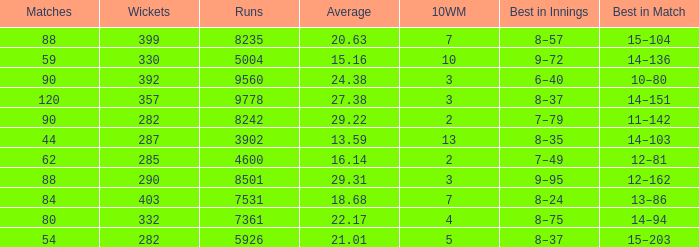What is the sum of runs that are associated with 10WM values over 13? None. 